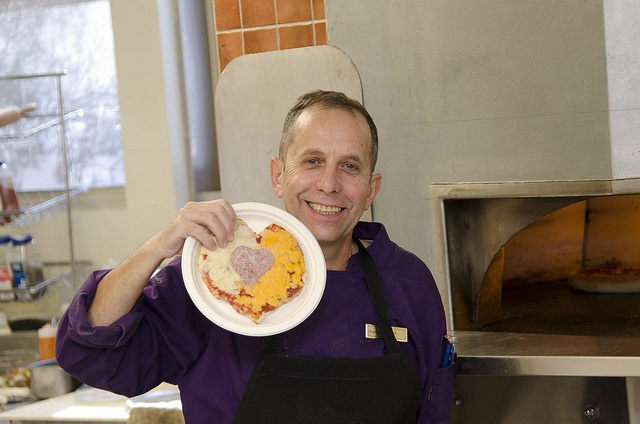Describe the objects in this image and their specific colors. I can see people in darkgray, black, tan, and gray tones, oven in darkgray, black, maroon, and gray tones, pizza in darkgray, orange, and tan tones, and pizza in maroon, black, and darkgray tones in this image. 